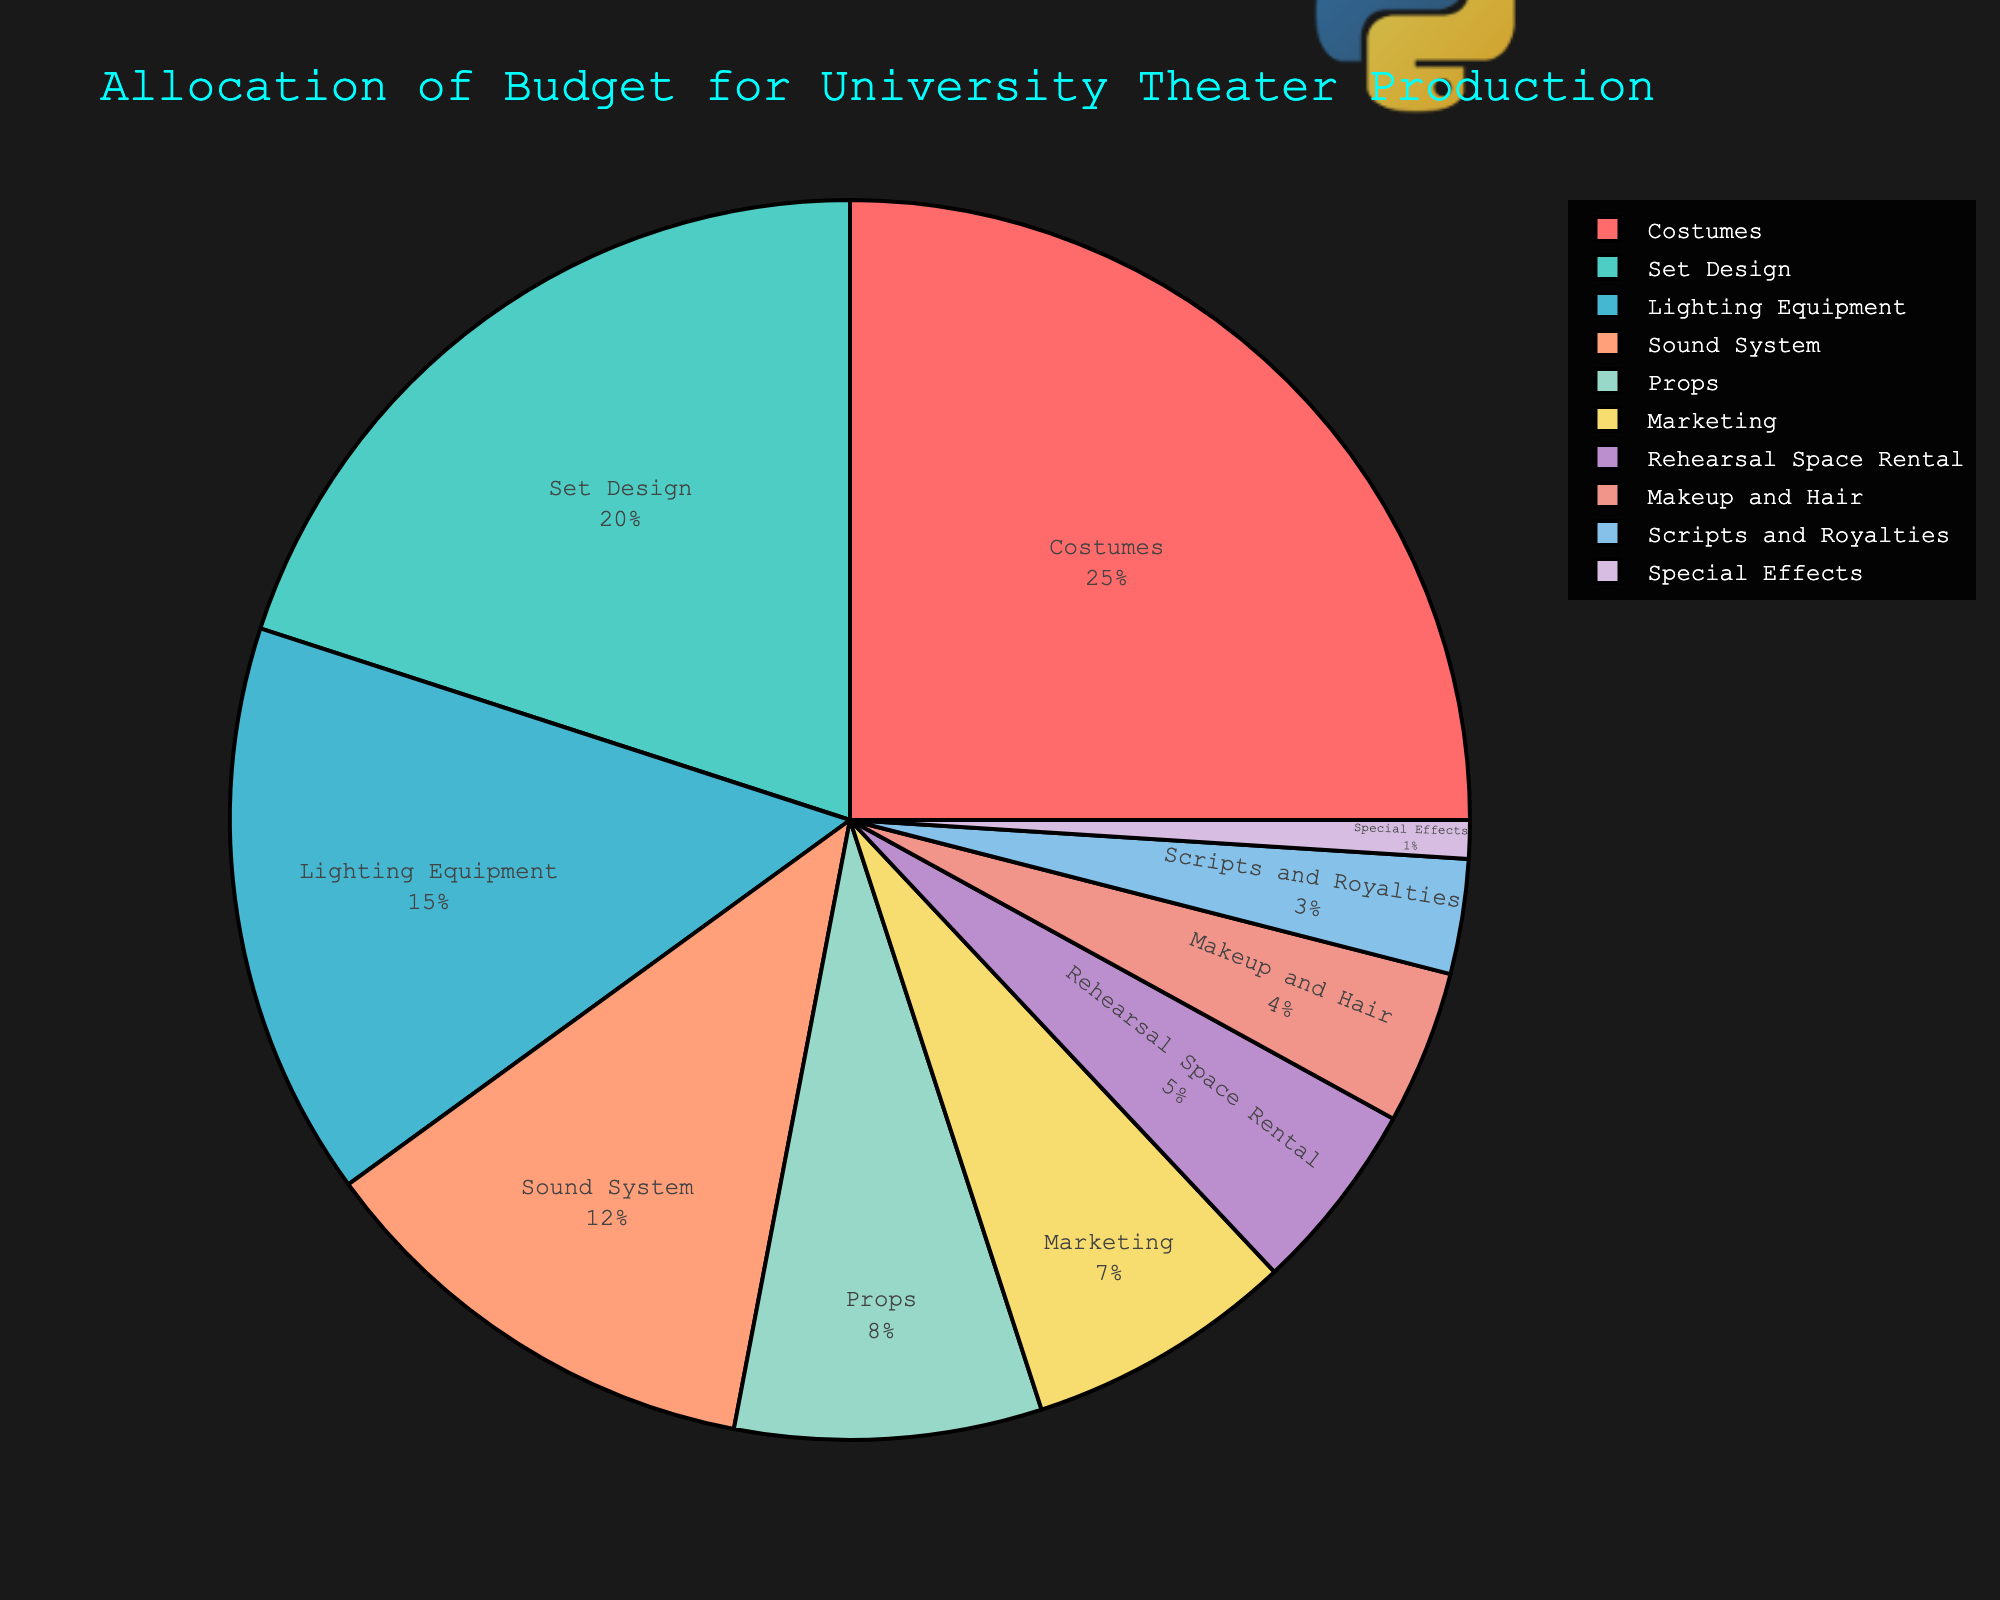Which category has the highest budget allocation? Look at the pie chart and identify the segment with the largest percentage value. Costumes has the highest with 25%.
Answer: Costumes Which two categories combined have a budget allocation of 35%? Identify two segments that collectively add up to 35%. Set Design (20%) and Lighting Equipment (15%) together make up 35%.
Answer: Set Design and Lighting Equipment How many categories have a budget allocation greater than 10%? Count the segments that have percentages above 10%. Costumes, Set Design, Lighting Equipment, and Sound System are above 10%. This amounts to 4 categories.
Answer: 4 Is the budget allocation for Marketing more or less than Props? Compare the percentages of Marketing (7%) and Props (8%). Marketing is less than Props.
Answer: Less Calculate the total budget allocation for Rehearsal Space Rental, Makeup and Hair, and Special Effects. Sum the percentages for these three categories: 5% + 4% + 1% = 10%.
Answer: 10% Which category has the least budget allocation? Look for the smallest segment in the pie chart. Special Effects has the smallest percentage at 1%.
Answer: Special Effects Compare the budget allocation for Costumes and Scripts and Royalties. Which one is greater and by how much? Costumes have 25% and Scripts and Royalties have 3%. The difference is 22%.
Answer: Costumes by 22% Combine the budget allocation percentages for Sound System and Rehearsal Space Rental. What is their combined percentage relative to the entire budget? Add Sound System (12%) and Rehearsal Space Rental (5%). Their combined total is 17% out of 100%.
Answer: 17% Which categories have the same amount of budget allocation as Marketing and Props combined? Marketing (7%) plus Props (8%) is 15%. Lighting Equipment also has 15%.
Answer: Lighting Equipment Is the budget allocation for Set Design more than double the budget for Scripts and Royalties? Set Design has 20%, and Scripts and Royalties has 3%. Double of 3% is 6%, and 20% is more than 6%.
Answer: Yes 